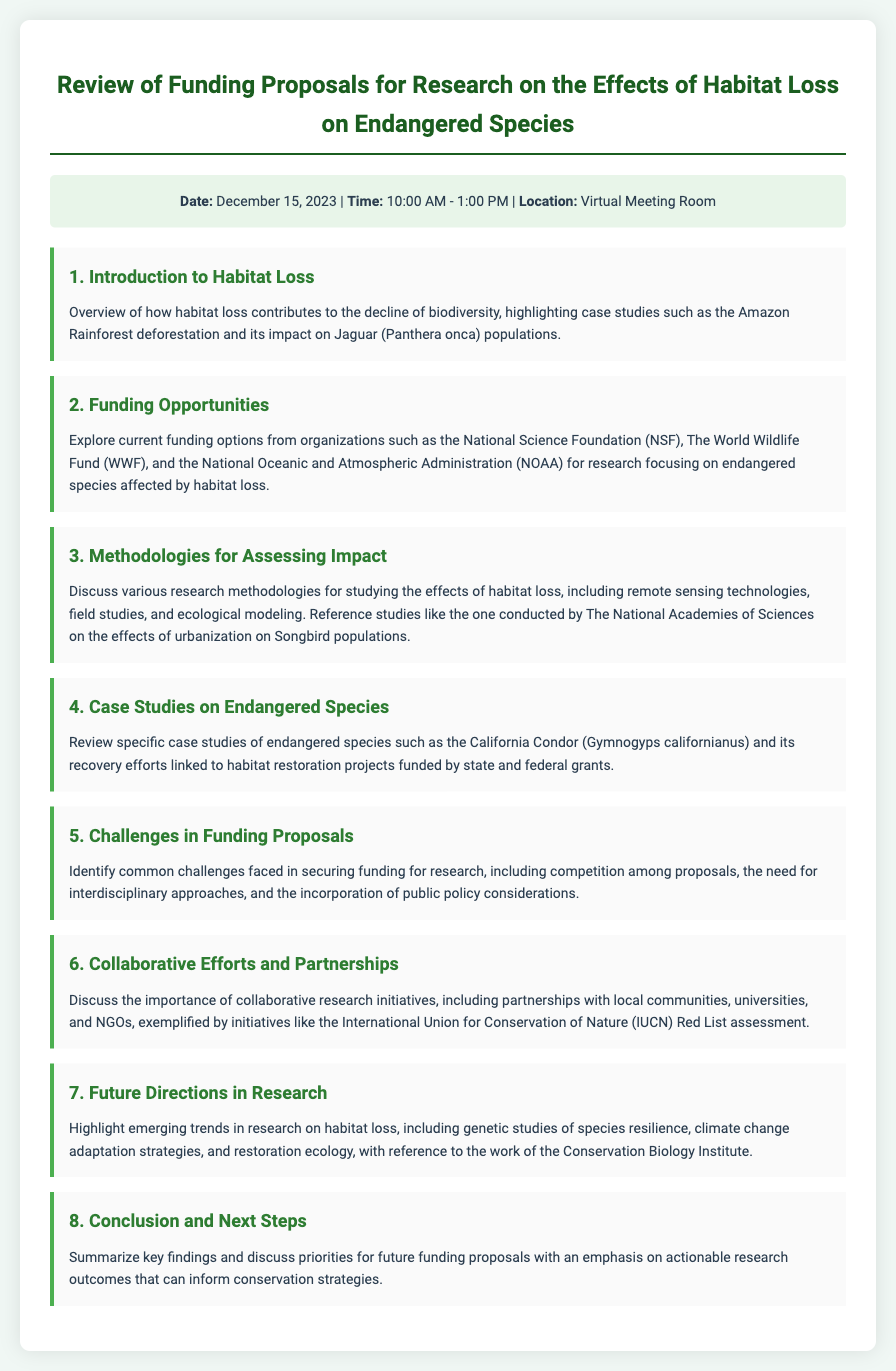What is the date of the meeting? The date of the meeting is explicitly mentioned in the document under meeting info.
Answer: December 15, 2023 What is the location of the meeting? The location of the meeting is specified in the document.
Answer: Virtual Meeting Room Which endangered species is highlighted in the introduction section? The introduction section lists a specific species affected by habitat loss in its case studies.
Answer: Jaguar (Panthera onca) What is the focus of the funding opportunities discussed? The funding opportunities section details specific research areas for which funding is available.
Answer: Research focusing on endangered species affected by habitat loss Which organization is mentioned as a funding source for the proposals? The document lists several organizations under funding opportunities.
Answer: National Science Foundation (NSF) What methodology is referenced for studying habitat loss impacts? The methodologies section discusses several different research methods.
Answer: Remote sensing technologies Name a specific case study mentioned for endangered species recovery. The case studies section provides an example of a successful recovery effort linked to funding.
Answer: California Condor (Gymnogyps californianus) What challenge is identified regarding funding proposals? The challenges section outlines common obstacles faced when applying for research funding.
Answer: Competition among proposals What future research area is highlighted in the document? The future directions section mentions emerging trends in research.
Answer: Genetic studies of species resilience 